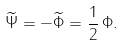Convert formula to latex. <formula><loc_0><loc_0><loc_500><loc_500>\widetilde { \Psi } = - \widetilde { \Phi } = \frac { 1 } { 2 } \, \Phi .</formula> 